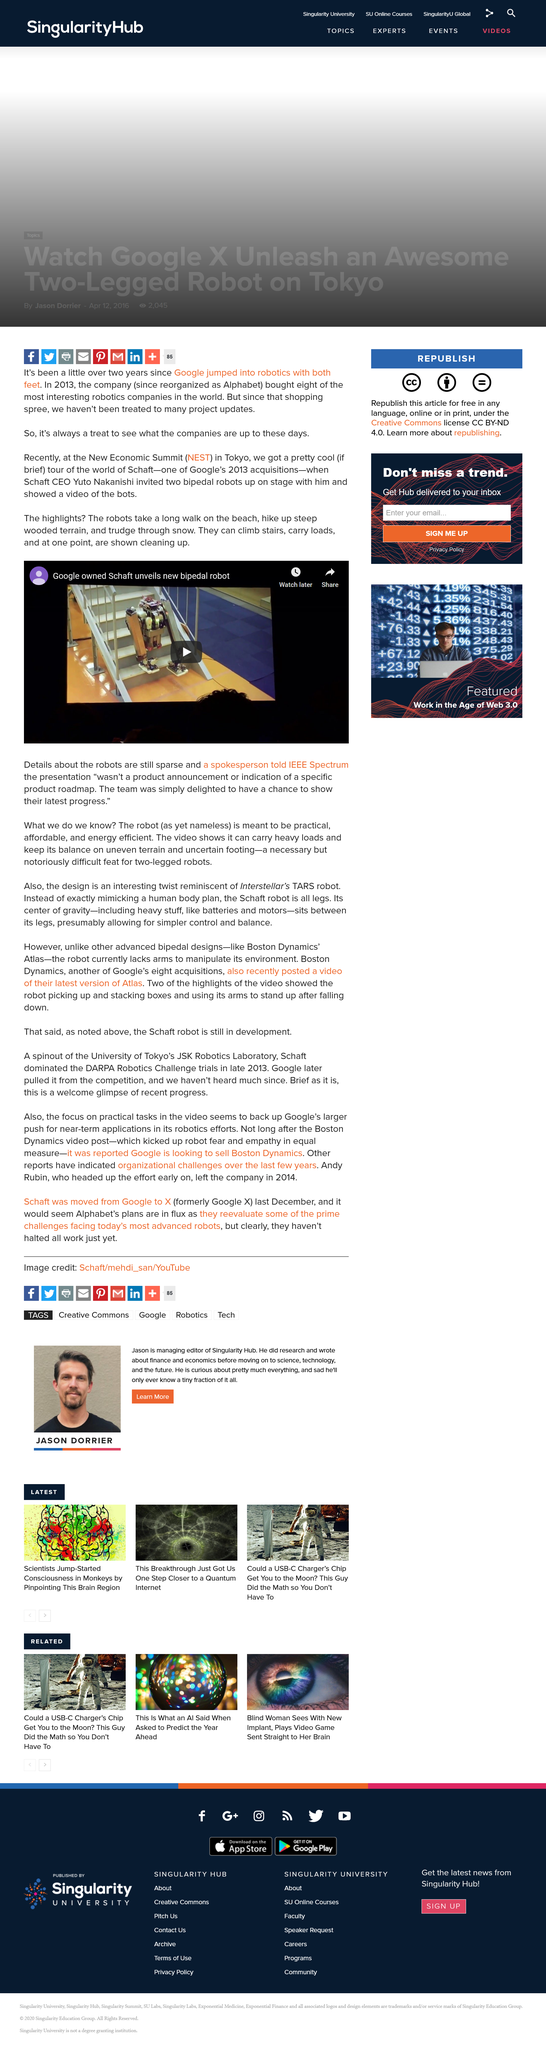Specify some key components in this picture. The New Economic Summit (NEST) was recently held in Tokyo. Google-owned company Schaft has unveiled a new bipedal robot in a video. 